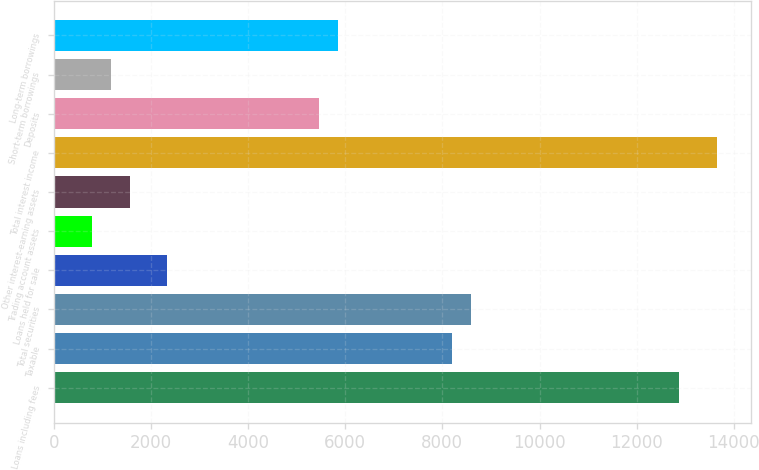Convert chart to OTSL. <chart><loc_0><loc_0><loc_500><loc_500><bar_chart><fcel>Loans including fees<fcel>Taxable<fcel>Total securities<fcel>Loans held for sale<fcel>Trading account assets<fcel>Other interest-earning assets<fcel>Total interest income<fcel>Deposits<fcel>Short-term borrowings<fcel>Long-term borrowings<nl><fcel>12879.9<fcel>8196.34<fcel>8586.64<fcel>2341.84<fcel>780.64<fcel>1561.24<fcel>13660.5<fcel>5464.24<fcel>1170.94<fcel>5854.54<nl></chart> 